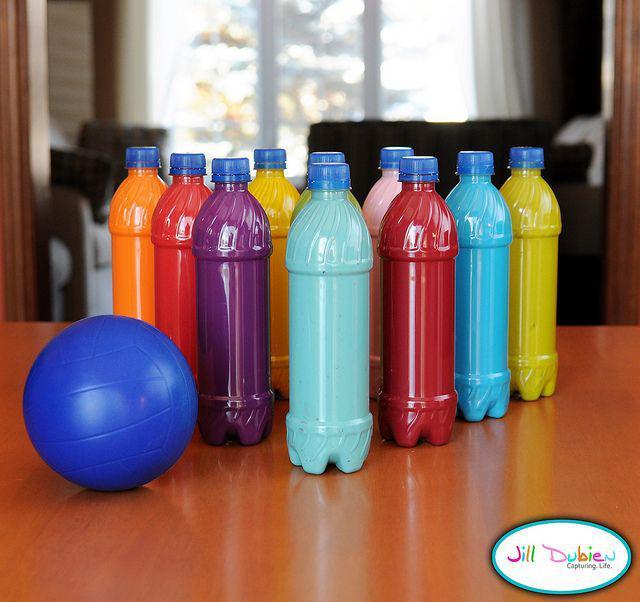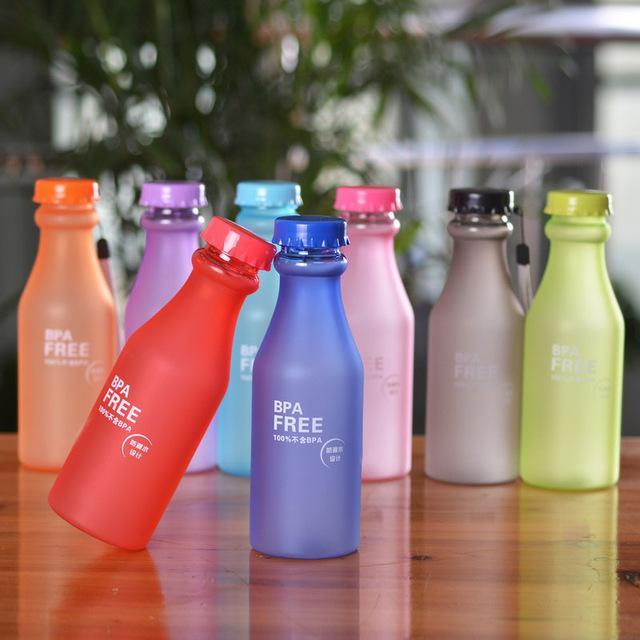The first image is the image on the left, the second image is the image on the right. For the images displayed, is the sentence "The right image shows one bottle leaning on an upright bottle, in front of a row of similar bottles shown in different colors." factually correct? Answer yes or no. Yes. The first image is the image on the left, the second image is the image on the right. Analyze the images presented: Is the assertion "One of the bottles is tilted and being propped up by another bottle." valid? Answer yes or no. Yes. 